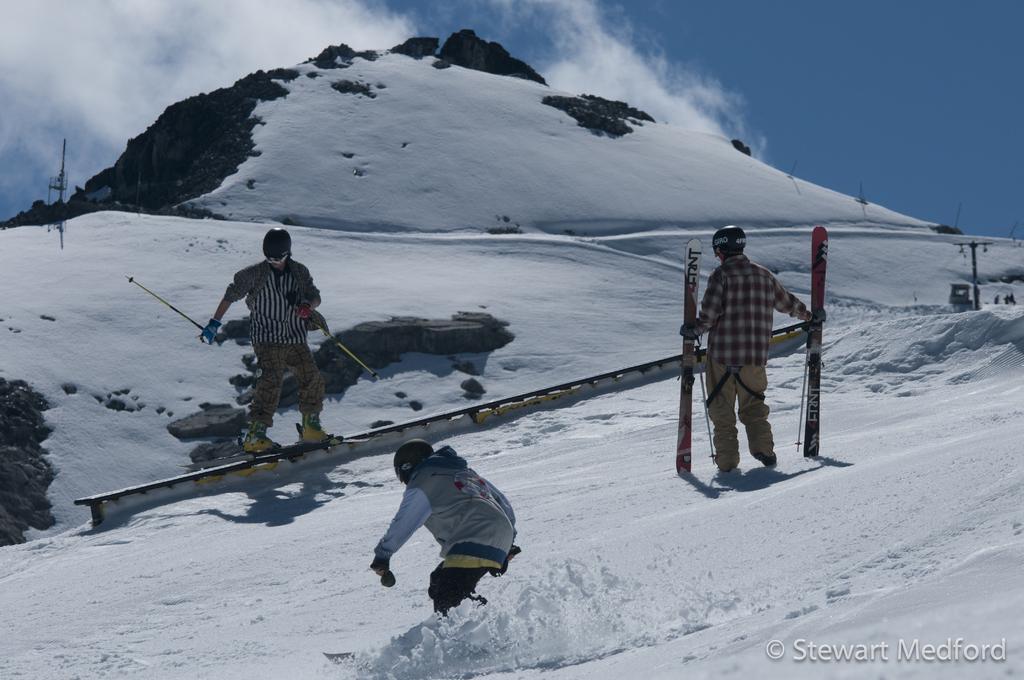Could you give a brief overview of what you see in this image? In the picture we can see a snow surface on it, we can see some persons with snowboards, sticks and wearing helmets and in the background, we can see a hill with snow and some part rock and behind it we can see a sky with clouds. 